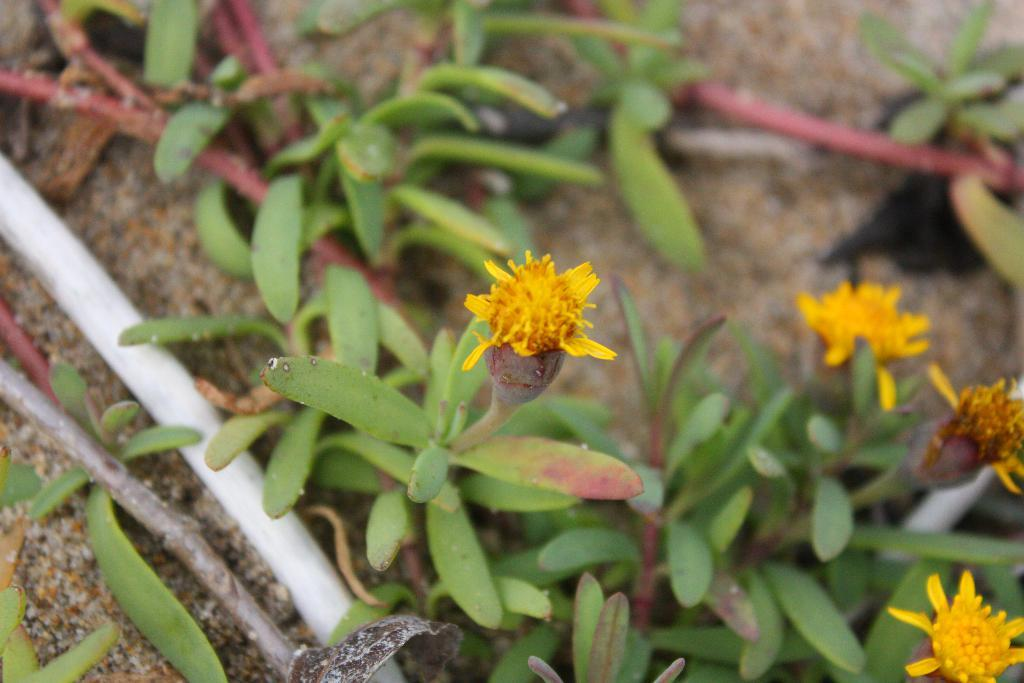What color are the flowers in the image? The flowers in the image are yellow. What color are the plants in the background of the image? The plants in the background of the image are green. What can be seen besides the flowers and plants in the image? There are pipes visible in the image. What type of library is depicted in the image? There is no library present in the image; it features flowers, plants, and pipes. How does the hydrant function in the image? There is no hydrant present in the image. 